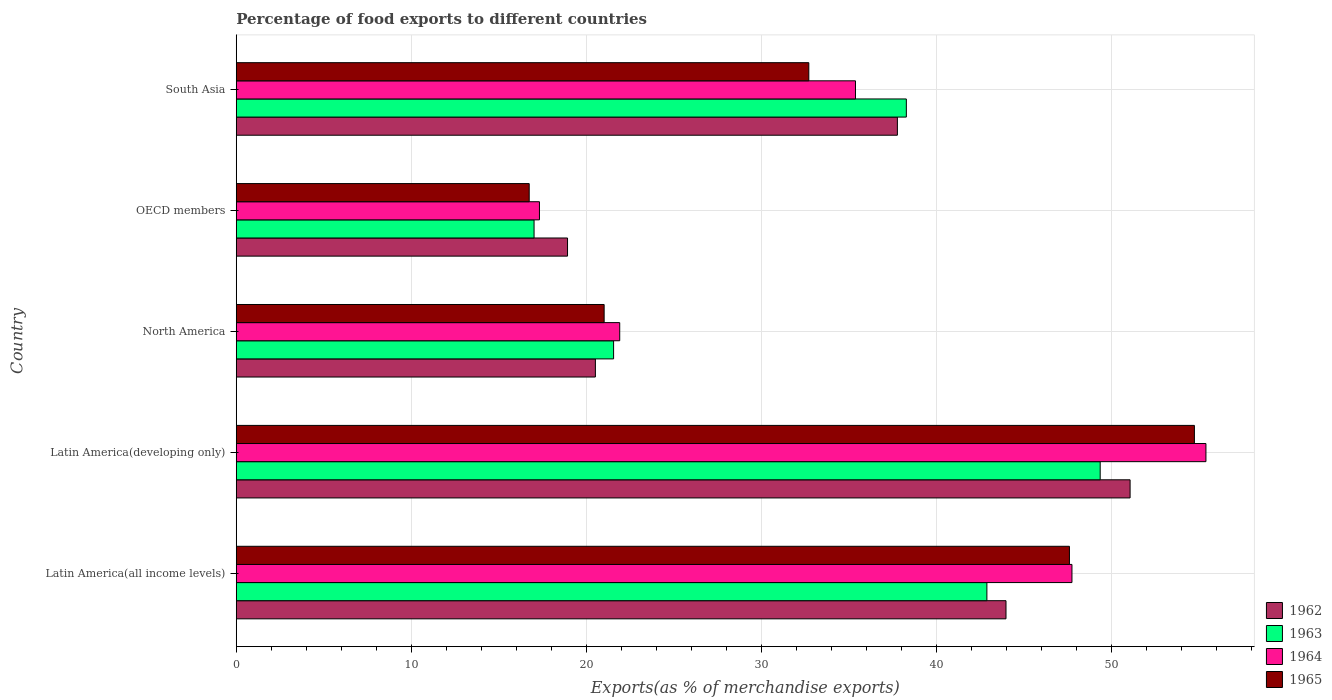How many different coloured bars are there?
Ensure brevity in your answer.  4. Are the number of bars on each tick of the Y-axis equal?
Provide a short and direct response. Yes. What is the label of the 4th group of bars from the top?
Keep it short and to the point. Latin America(developing only). In how many cases, is the number of bars for a given country not equal to the number of legend labels?
Offer a terse response. 0. What is the percentage of exports to different countries in 1963 in South Asia?
Your answer should be compact. 38.26. Across all countries, what is the maximum percentage of exports to different countries in 1962?
Provide a short and direct response. 51.04. Across all countries, what is the minimum percentage of exports to different countries in 1962?
Your answer should be very brief. 18.92. In which country was the percentage of exports to different countries in 1965 maximum?
Your answer should be very brief. Latin America(developing only). What is the total percentage of exports to different countries in 1963 in the graph?
Provide a short and direct response. 169.02. What is the difference between the percentage of exports to different countries in 1962 in Latin America(all income levels) and that in South Asia?
Your answer should be compact. 6.2. What is the difference between the percentage of exports to different countries in 1963 in Latin America(all income levels) and the percentage of exports to different countries in 1962 in Latin America(developing only)?
Keep it short and to the point. -8.18. What is the average percentage of exports to different countries in 1965 per country?
Give a very brief answer. 34.54. What is the difference between the percentage of exports to different countries in 1962 and percentage of exports to different countries in 1964 in North America?
Provide a succinct answer. -1.39. What is the ratio of the percentage of exports to different countries in 1965 in Latin America(developing only) to that in OECD members?
Keep it short and to the point. 3.27. Is the difference between the percentage of exports to different countries in 1962 in Latin America(all income levels) and OECD members greater than the difference between the percentage of exports to different countries in 1964 in Latin America(all income levels) and OECD members?
Offer a very short reply. No. What is the difference between the highest and the second highest percentage of exports to different countries in 1963?
Keep it short and to the point. 6.47. What is the difference between the highest and the lowest percentage of exports to different countries in 1964?
Provide a succinct answer. 38.06. In how many countries, is the percentage of exports to different countries in 1962 greater than the average percentage of exports to different countries in 1962 taken over all countries?
Offer a very short reply. 3. What does the 2nd bar from the top in North America represents?
Offer a very short reply. 1964. What does the 1st bar from the bottom in OECD members represents?
Your answer should be compact. 1962. How are the legend labels stacked?
Make the answer very short. Vertical. What is the title of the graph?
Offer a terse response. Percentage of food exports to different countries. What is the label or title of the X-axis?
Provide a short and direct response. Exports(as % of merchandise exports). What is the Exports(as % of merchandise exports) in 1962 in Latin America(all income levels)?
Your answer should be compact. 43.96. What is the Exports(as % of merchandise exports) in 1963 in Latin America(all income levels)?
Your response must be concise. 42.86. What is the Exports(as % of merchandise exports) in 1964 in Latin America(all income levels)?
Offer a very short reply. 47.72. What is the Exports(as % of merchandise exports) in 1965 in Latin America(all income levels)?
Ensure brevity in your answer.  47.58. What is the Exports(as % of merchandise exports) of 1962 in Latin America(developing only)?
Offer a terse response. 51.04. What is the Exports(as % of merchandise exports) in 1963 in Latin America(developing only)?
Your response must be concise. 49.33. What is the Exports(as % of merchandise exports) in 1964 in Latin America(developing only)?
Offer a very short reply. 55.37. What is the Exports(as % of merchandise exports) of 1965 in Latin America(developing only)?
Give a very brief answer. 54.71. What is the Exports(as % of merchandise exports) in 1962 in North America?
Keep it short and to the point. 20.51. What is the Exports(as % of merchandise exports) in 1963 in North America?
Your answer should be compact. 21.55. What is the Exports(as % of merchandise exports) of 1964 in North America?
Your answer should be compact. 21.9. What is the Exports(as % of merchandise exports) of 1965 in North America?
Offer a very short reply. 21.01. What is the Exports(as % of merchandise exports) of 1962 in OECD members?
Provide a short and direct response. 18.92. What is the Exports(as % of merchandise exports) in 1963 in OECD members?
Your response must be concise. 17.01. What is the Exports(as % of merchandise exports) of 1964 in OECD members?
Your answer should be compact. 17.31. What is the Exports(as % of merchandise exports) of 1965 in OECD members?
Make the answer very short. 16.73. What is the Exports(as % of merchandise exports) of 1962 in South Asia?
Ensure brevity in your answer.  37.75. What is the Exports(as % of merchandise exports) in 1963 in South Asia?
Provide a succinct answer. 38.26. What is the Exports(as % of merchandise exports) in 1964 in South Asia?
Your answer should be compact. 35.36. What is the Exports(as % of merchandise exports) of 1965 in South Asia?
Offer a very short reply. 32.7. Across all countries, what is the maximum Exports(as % of merchandise exports) of 1962?
Offer a terse response. 51.04. Across all countries, what is the maximum Exports(as % of merchandise exports) in 1963?
Offer a very short reply. 49.33. Across all countries, what is the maximum Exports(as % of merchandise exports) in 1964?
Make the answer very short. 55.37. Across all countries, what is the maximum Exports(as % of merchandise exports) of 1965?
Your answer should be very brief. 54.71. Across all countries, what is the minimum Exports(as % of merchandise exports) of 1962?
Your answer should be very brief. 18.92. Across all countries, what is the minimum Exports(as % of merchandise exports) in 1963?
Your response must be concise. 17.01. Across all countries, what is the minimum Exports(as % of merchandise exports) of 1964?
Provide a succinct answer. 17.31. Across all countries, what is the minimum Exports(as % of merchandise exports) of 1965?
Provide a succinct answer. 16.73. What is the total Exports(as % of merchandise exports) in 1962 in the graph?
Your answer should be compact. 172.18. What is the total Exports(as % of merchandise exports) in 1963 in the graph?
Offer a very short reply. 169.02. What is the total Exports(as % of merchandise exports) of 1964 in the graph?
Your answer should be compact. 177.67. What is the total Exports(as % of merchandise exports) in 1965 in the graph?
Provide a succinct answer. 172.72. What is the difference between the Exports(as % of merchandise exports) of 1962 in Latin America(all income levels) and that in Latin America(developing only)?
Ensure brevity in your answer.  -7.09. What is the difference between the Exports(as % of merchandise exports) in 1963 in Latin America(all income levels) and that in Latin America(developing only)?
Offer a terse response. -6.47. What is the difference between the Exports(as % of merchandise exports) in 1964 in Latin America(all income levels) and that in Latin America(developing only)?
Your answer should be compact. -7.65. What is the difference between the Exports(as % of merchandise exports) in 1965 in Latin America(all income levels) and that in Latin America(developing only)?
Your response must be concise. -7.14. What is the difference between the Exports(as % of merchandise exports) of 1962 in Latin America(all income levels) and that in North America?
Provide a succinct answer. 23.45. What is the difference between the Exports(as % of merchandise exports) in 1963 in Latin America(all income levels) and that in North America?
Provide a short and direct response. 21.32. What is the difference between the Exports(as % of merchandise exports) in 1964 in Latin America(all income levels) and that in North America?
Offer a terse response. 25.82. What is the difference between the Exports(as % of merchandise exports) in 1965 in Latin America(all income levels) and that in North America?
Offer a terse response. 26.57. What is the difference between the Exports(as % of merchandise exports) in 1962 in Latin America(all income levels) and that in OECD members?
Your response must be concise. 25.04. What is the difference between the Exports(as % of merchandise exports) in 1963 in Latin America(all income levels) and that in OECD members?
Give a very brief answer. 25.86. What is the difference between the Exports(as % of merchandise exports) of 1964 in Latin America(all income levels) and that in OECD members?
Ensure brevity in your answer.  30.41. What is the difference between the Exports(as % of merchandise exports) in 1965 in Latin America(all income levels) and that in OECD members?
Your answer should be very brief. 30.85. What is the difference between the Exports(as % of merchandise exports) of 1962 in Latin America(all income levels) and that in South Asia?
Your answer should be compact. 6.2. What is the difference between the Exports(as % of merchandise exports) in 1963 in Latin America(all income levels) and that in South Asia?
Offer a very short reply. 4.6. What is the difference between the Exports(as % of merchandise exports) in 1964 in Latin America(all income levels) and that in South Asia?
Give a very brief answer. 12.36. What is the difference between the Exports(as % of merchandise exports) in 1965 in Latin America(all income levels) and that in South Asia?
Provide a succinct answer. 14.88. What is the difference between the Exports(as % of merchandise exports) of 1962 in Latin America(developing only) and that in North America?
Make the answer very short. 30.53. What is the difference between the Exports(as % of merchandise exports) in 1963 in Latin America(developing only) and that in North America?
Your answer should be very brief. 27.79. What is the difference between the Exports(as % of merchandise exports) in 1964 in Latin America(developing only) and that in North America?
Keep it short and to the point. 33.48. What is the difference between the Exports(as % of merchandise exports) in 1965 in Latin America(developing only) and that in North America?
Give a very brief answer. 33.71. What is the difference between the Exports(as % of merchandise exports) of 1962 in Latin America(developing only) and that in OECD members?
Make the answer very short. 32.12. What is the difference between the Exports(as % of merchandise exports) in 1963 in Latin America(developing only) and that in OECD members?
Your answer should be very brief. 32.33. What is the difference between the Exports(as % of merchandise exports) in 1964 in Latin America(developing only) and that in OECD members?
Offer a terse response. 38.06. What is the difference between the Exports(as % of merchandise exports) of 1965 in Latin America(developing only) and that in OECD members?
Offer a terse response. 37.99. What is the difference between the Exports(as % of merchandise exports) in 1962 in Latin America(developing only) and that in South Asia?
Your answer should be compact. 13.29. What is the difference between the Exports(as % of merchandise exports) in 1963 in Latin America(developing only) and that in South Asia?
Offer a very short reply. 11.07. What is the difference between the Exports(as % of merchandise exports) in 1964 in Latin America(developing only) and that in South Asia?
Offer a very short reply. 20.01. What is the difference between the Exports(as % of merchandise exports) in 1965 in Latin America(developing only) and that in South Asia?
Offer a terse response. 22.02. What is the difference between the Exports(as % of merchandise exports) in 1962 in North America and that in OECD members?
Your answer should be very brief. 1.59. What is the difference between the Exports(as % of merchandise exports) in 1963 in North America and that in OECD members?
Make the answer very short. 4.54. What is the difference between the Exports(as % of merchandise exports) in 1964 in North America and that in OECD members?
Provide a succinct answer. 4.58. What is the difference between the Exports(as % of merchandise exports) in 1965 in North America and that in OECD members?
Give a very brief answer. 4.28. What is the difference between the Exports(as % of merchandise exports) of 1962 in North America and that in South Asia?
Provide a short and direct response. -17.25. What is the difference between the Exports(as % of merchandise exports) in 1963 in North America and that in South Asia?
Your answer should be very brief. -16.72. What is the difference between the Exports(as % of merchandise exports) of 1964 in North America and that in South Asia?
Provide a succinct answer. -13.46. What is the difference between the Exports(as % of merchandise exports) of 1965 in North America and that in South Asia?
Your answer should be very brief. -11.69. What is the difference between the Exports(as % of merchandise exports) of 1962 in OECD members and that in South Asia?
Your answer should be compact. -18.84. What is the difference between the Exports(as % of merchandise exports) of 1963 in OECD members and that in South Asia?
Make the answer very short. -21.26. What is the difference between the Exports(as % of merchandise exports) of 1964 in OECD members and that in South Asia?
Make the answer very short. -18.05. What is the difference between the Exports(as % of merchandise exports) of 1965 in OECD members and that in South Asia?
Keep it short and to the point. -15.97. What is the difference between the Exports(as % of merchandise exports) in 1962 in Latin America(all income levels) and the Exports(as % of merchandise exports) in 1963 in Latin America(developing only)?
Your answer should be very brief. -5.38. What is the difference between the Exports(as % of merchandise exports) of 1962 in Latin America(all income levels) and the Exports(as % of merchandise exports) of 1964 in Latin America(developing only)?
Your response must be concise. -11.42. What is the difference between the Exports(as % of merchandise exports) of 1962 in Latin America(all income levels) and the Exports(as % of merchandise exports) of 1965 in Latin America(developing only)?
Ensure brevity in your answer.  -10.76. What is the difference between the Exports(as % of merchandise exports) of 1963 in Latin America(all income levels) and the Exports(as % of merchandise exports) of 1964 in Latin America(developing only)?
Provide a short and direct response. -12.51. What is the difference between the Exports(as % of merchandise exports) in 1963 in Latin America(all income levels) and the Exports(as % of merchandise exports) in 1965 in Latin America(developing only)?
Your answer should be very brief. -11.85. What is the difference between the Exports(as % of merchandise exports) of 1964 in Latin America(all income levels) and the Exports(as % of merchandise exports) of 1965 in Latin America(developing only)?
Offer a very short reply. -6.99. What is the difference between the Exports(as % of merchandise exports) in 1962 in Latin America(all income levels) and the Exports(as % of merchandise exports) in 1963 in North America?
Offer a very short reply. 22.41. What is the difference between the Exports(as % of merchandise exports) in 1962 in Latin America(all income levels) and the Exports(as % of merchandise exports) in 1964 in North America?
Your answer should be compact. 22.06. What is the difference between the Exports(as % of merchandise exports) of 1962 in Latin America(all income levels) and the Exports(as % of merchandise exports) of 1965 in North America?
Provide a short and direct response. 22.95. What is the difference between the Exports(as % of merchandise exports) in 1963 in Latin America(all income levels) and the Exports(as % of merchandise exports) in 1964 in North America?
Provide a short and direct response. 20.97. What is the difference between the Exports(as % of merchandise exports) in 1963 in Latin America(all income levels) and the Exports(as % of merchandise exports) in 1965 in North America?
Offer a terse response. 21.86. What is the difference between the Exports(as % of merchandise exports) of 1964 in Latin America(all income levels) and the Exports(as % of merchandise exports) of 1965 in North America?
Your response must be concise. 26.71. What is the difference between the Exports(as % of merchandise exports) in 1962 in Latin America(all income levels) and the Exports(as % of merchandise exports) in 1963 in OECD members?
Your answer should be compact. 26.95. What is the difference between the Exports(as % of merchandise exports) in 1962 in Latin America(all income levels) and the Exports(as % of merchandise exports) in 1964 in OECD members?
Ensure brevity in your answer.  26.64. What is the difference between the Exports(as % of merchandise exports) of 1962 in Latin America(all income levels) and the Exports(as % of merchandise exports) of 1965 in OECD members?
Provide a short and direct response. 27.23. What is the difference between the Exports(as % of merchandise exports) in 1963 in Latin America(all income levels) and the Exports(as % of merchandise exports) in 1964 in OECD members?
Make the answer very short. 25.55. What is the difference between the Exports(as % of merchandise exports) of 1963 in Latin America(all income levels) and the Exports(as % of merchandise exports) of 1965 in OECD members?
Offer a very short reply. 26.14. What is the difference between the Exports(as % of merchandise exports) of 1964 in Latin America(all income levels) and the Exports(as % of merchandise exports) of 1965 in OECD members?
Make the answer very short. 30.99. What is the difference between the Exports(as % of merchandise exports) of 1962 in Latin America(all income levels) and the Exports(as % of merchandise exports) of 1963 in South Asia?
Make the answer very short. 5.69. What is the difference between the Exports(as % of merchandise exports) of 1962 in Latin America(all income levels) and the Exports(as % of merchandise exports) of 1964 in South Asia?
Make the answer very short. 8.6. What is the difference between the Exports(as % of merchandise exports) of 1962 in Latin America(all income levels) and the Exports(as % of merchandise exports) of 1965 in South Asia?
Your response must be concise. 11.26. What is the difference between the Exports(as % of merchandise exports) in 1963 in Latin America(all income levels) and the Exports(as % of merchandise exports) in 1964 in South Asia?
Your response must be concise. 7.5. What is the difference between the Exports(as % of merchandise exports) in 1963 in Latin America(all income levels) and the Exports(as % of merchandise exports) in 1965 in South Asia?
Keep it short and to the point. 10.17. What is the difference between the Exports(as % of merchandise exports) in 1964 in Latin America(all income levels) and the Exports(as % of merchandise exports) in 1965 in South Asia?
Make the answer very short. 15.03. What is the difference between the Exports(as % of merchandise exports) in 1962 in Latin America(developing only) and the Exports(as % of merchandise exports) in 1963 in North America?
Ensure brevity in your answer.  29.49. What is the difference between the Exports(as % of merchandise exports) in 1962 in Latin America(developing only) and the Exports(as % of merchandise exports) in 1964 in North America?
Provide a short and direct response. 29.14. What is the difference between the Exports(as % of merchandise exports) of 1962 in Latin America(developing only) and the Exports(as % of merchandise exports) of 1965 in North America?
Offer a very short reply. 30.03. What is the difference between the Exports(as % of merchandise exports) in 1963 in Latin America(developing only) and the Exports(as % of merchandise exports) in 1964 in North America?
Offer a terse response. 27.44. What is the difference between the Exports(as % of merchandise exports) in 1963 in Latin America(developing only) and the Exports(as % of merchandise exports) in 1965 in North America?
Provide a succinct answer. 28.33. What is the difference between the Exports(as % of merchandise exports) of 1964 in Latin America(developing only) and the Exports(as % of merchandise exports) of 1965 in North America?
Provide a short and direct response. 34.37. What is the difference between the Exports(as % of merchandise exports) in 1962 in Latin America(developing only) and the Exports(as % of merchandise exports) in 1963 in OECD members?
Give a very brief answer. 34.04. What is the difference between the Exports(as % of merchandise exports) in 1962 in Latin America(developing only) and the Exports(as % of merchandise exports) in 1964 in OECD members?
Your answer should be compact. 33.73. What is the difference between the Exports(as % of merchandise exports) of 1962 in Latin America(developing only) and the Exports(as % of merchandise exports) of 1965 in OECD members?
Make the answer very short. 34.31. What is the difference between the Exports(as % of merchandise exports) of 1963 in Latin America(developing only) and the Exports(as % of merchandise exports) of 1964 in OECD members?
Your answer should be very brief. 32.02. What is the difference between the Exports(as % of merchandise exports) of 1963 in Latin America(developing only) and the Exports(as % of merchandise exports) of 1965 in OECD members?
Offer a terse response. 32.61. What is the difference between the Exports(as % of merchandise exports) in 1964 in Latin America(developing only) and the Exports(as % of merchandise exports) in 1965 in OECD members?
Offer a terse response. 38.64. What is the difference between the Exports(as % of merchandise exports) of 1962 in Latin America(developing only) and the Exports(as % of merchandise exports) of 1963 in South Asia?
Provide a short and direct response. 12.78. What is the difference between the Exports(as % of merchandise exports) in 1962 in Latin America(developing only) and the Exports(as % of merchandise exports) in 1964 in South Asia?
Provide a short and direct response. 15.68. What is the difference between the Exports(as % of merchandise exports) in 1962 in Latin America(developing only) and the Exports(as % of merchandise exports) in 1965 in South Asia?
Provide a short and direct response. 18.35. What is the difference between the Exports(as % of merchandise exports) in 1963 in Latin America(developing only) and the Exports(as % of merchandise exports) in 1964 in South Asia?
Provide a short and direct response. 13.97. What is the difference between the Exports(as % of merchandise exports) in 1963 in Latin America(developing only) and the Exports(as % of merchandise exports) in 1965 in South Asia?
Ensure brevity in your answer.  16.64. What is the difference between the Exports(as % of merchandise exports) of 1964 in Latin America(developing only) and the Exports(as % of merchandise exports) of 1965 in South Asia?
Ensure brevity in your answer.  22.68. What is the difference between the Exports(as % of merchandise exports) in 1962 in North America and the Exports(as % of merchandise exports) in 1963 in OECD members?
Provide a short and direct response. 3.5. What is the difference between the Exports(as % of merchandise exports) in 1962 in North America and the Exports(as % of merchandise exports) in 1964 in OECD members?
Your response must be concise. 3.19. What is the difference between the Exports(as % of merchandise exports) of 1962 in North America and the Exports(as % of merchandise exports) of 1965 in OECD members?
Your response must be concise. 3.78. What is the difference between the Exports(as % of merchandise exports) of 1963 in North America and the Exports(as % of merchandise exports) of 1964 in OECD members?
Your answer should be compact. 4.23. What is the difference between the Exports(as % of merchandise exports) of 1963 in North America and the Exports(as % of merchandise exports) of 1965 in OECD members?
Offer a terse response. 4.82. What is the difference between the Exports(as % of merchandise exports) in 1964 in North America and the Exports(as % of merchandise exports) in 1965 in OECD members?
Your answer should be very brief. 5.17. What is the difference between the Exports(as % of merchandise exports) of 1962 in North America and the Exports(as % of merchandise exports) of 1963 in South Asia?
Make the answer very short. -17.76. What is the difference between the Exports(as % of merchandise exports) in 1962 in North America and the Exports(as % of merchandise exports) in 1964 in South Asia?
Give a very brief answer. -14.85. What is the difference between the Exports(as % of merchandise exports) of 1962 in North America and the Exports(as % of merchandise exports) of 1965 in South Asia?
Keep it short and to the point. -12.19. What is the difference between the Exports(as % of merchandise exports) of 1963 in North America and the Exports(as % of merchandise exports) of 1964 in South Asia?
Your response must be concise. -13.81. What is the difference between the Exports(as % of merchandise exports) of 1963 in North America and the Exports(as % of merchandise exports) of 1965 in South Asia?
Your answer should be very brief. -11.15. What is the difference between the Exports(as % of merchandise exports) of 1964 in North America and the Exports(as % of merchandise exports) of 1965 in South Asia?
Your response must be concise. -10.8. What is the difference between the Exports(as % of merchandise exports) of 1962 in OECD members and the Exports(as % of merchandise exports) of 1963 in South Asia?
Your response must be concise. -19.35. What is the difference between the Exports(as % of merchandise exports) in 1962 in OECD members and the Exports(as % of merchandise exports) in 1964 in South Asia?
Keep it short and to the point. -16.44. What is the difference between the Exports(as % of merchandise exports) of 1962 in OECD members and the Exports(as % of merchandise exports) of 1965 in South Asia?
Give a very brief answer. -13.78. What is the difference between the Exports(as % of merchandise exports) in 1963 in OECD members and the Exports(as % of merchandise exports) in 1964 in South Asia?
Offer a very short reply. -18.35. What is the difference between the Exports(as % of merchandise exports) of 1963 in OECD members and the Exports(as % of merchandise exports) of 1965 in South Asia?
Your response must be concise. -15.69. What is the difference between the Exports(as % of merchandise exports) of 1964 in OECD members and the Exports(as % of merchandise exports) of 1965 in South Asia?
Make the answer very short. -15.38. What is the average Exports(as % of merchandise exports) in 1962 per country?
Ensure brevity in your answer.  34.44. What is the average Exports(as % of merchandise exports) in 1963 per country?
Give a very brief answer. 33.8. What is the average Exports(as % of merchandise exports) in 1964 per country?
Provide a short and direct response. 35.53. What is the average Exports(as % of merchandise exports) of 1965 per country?
Your response must be concise. 34.54. What is the difference between the Exports(as % of merchandise exports) of 1962 and Exports(as % of merchandise exports) of 1963 in Latin America(all income levels)?
Offer a very short reply. 1.09. What is the difference between the Exports(as % of merchandise exports) of 1962 and Exports(as % of merchandise exports) of 1964 in Latin America(all income levels)?
Your response must be concise. -3.77. What is the difference between the Exports(as % of merchandise exports) in 1962 and Exports(as % of merchandise exports) in 1965 in Latin America(all income levels)?
Make the answer very short. -3.62. What is the difference between the Exports(as % of merchandise exports) of 1963 and Exports(as % of merchandise exports) of 1964 in Latin America(all income levels)?
Offer a terse response. -4.86. What is the difference between the Exports(as % of merchandise exports) of 1963 and Exports(as % of merchandise exports) of 1965 in Latin America(all income levels)?
Your answer should be compact. -4.71. What is the difference between the Exports(as % of merchandise exports) in 1964 and Exports(as % of merchandise exports) in 1965 in Latin America(all income levels)?
Your answer should be very brief. 0.14. What is the difference between the Exports(as % of merchandise exports) in 1962 and Exports(as % of merchandise exports) in 1963 in Latin America(developing only)?
Give a very brief answer. 1.71. What is the difference between the Exports(as % of merchandise exports) of 1962 and Exports(as % of merchandise exports) of 1964 in Latin America(developing only)?
Your answer should be very brief. -4.33. What is the difference between the Exports(as % of merchandise exports) in 1962 and Exports(as % of merchandise exports) in 1965 in Latin America(developing only)?
Keep it short and to the point. -3.67. What is the difference between the Exports(as % of merchandise exports) of 1963 and Exports(as % of merchandise exports) of 1964 in Latin America(developing only)?
Ensure brevity in your answer.  -6.04. What is the difference between the Exports(as % of merchandise exports) of 1963 and Exports(as % of merchandise exports) of 1965 in Latin America(developing only)?
Give a very brief answer. -5.38. What is the difference between the Exports(as % of merchandise exports) of 1964 and Exports(as % of merchandise exports) of 1965 in Latin America(developing only)?
Your answer should be very brief. 0.66. What is the difference between the Exports(as % of merchandise exports) in 1962 and Exports(as % of merchandise exports) in 1963 in North America?
Your answer should be compact. -1.04. What is the difference between the Exports(as % of merchandise exports) in 1962 and Exports(as % of merchandise exports) in 1964 in North America?
Offer a terse response. -1.39. What is the difference between the Exports(as % of merchandise exports) in 1962 and Exports(as % of merchandise exports) in 1965 in North America?
Give a very brief answer. -0.5. What is the difference between the Exports(as % of merchandise exports) in 1963 and Exports(as % of merchandise exports) in 1964 in North America?
Offer a very short reply. -0.35. What is the difference between the Exports(as % of merchandise exports) of 1963 and Exports(as % of merchandise exports) of 1965 in North America?
Provide a succinct answer. 0.54. What is the difference between the Exports(as % of merchandise exports) of 1964 and Exports(as % of merchandise exports) of 1965 in North America?
Your answer should be compact. 0.89. What is the difference between the Exports(as % of merchandise exports) in 1962 and Exports(as % of merchandise exports) in 1963 in OECD members?
Keep it short and to the point. 1.91. What is the difference between the Exports(as % of merchandise exports) in 1962 and Exports(as % of merchandise exports) in 1964 in OECD members?
Your answer should be very brief. 1.6. What is the difference between the Exports(as % of merchandise exports) of 1962 and Exports(as % of merchandise exports) of 1965 in OECD members?
Your response must be concise. 2.19. What is the difference between the Exports(as % of merchandise exports) in 1963 and Exports(as % of merchandise exports) in 1964 in OECD members?
Offer a terse response. -0.31. What is the difference between the Exports(as % of merchandise exports) in 1963 and Exports(as % of merchandise exports) in 1965 in OECD members?
Provide a succinct answer. 0.28. What is the difference between the Exports(as % of merchandise exports) in 1964 and Exports(as % of merchandise exports) in 1965 in OECD members?
Give a very brief answer. 0.59. What is the difference between the Exports(as % of merchandise exports) in 1962 and Exports(as % of merchandise exports) in 1963 in South Asia?
Ensure brevity in your answer.  -0.51. What is the difference between the Exports(as % of merchandise exports) of 1962 and Exports(as % of merchandise exports) of 1964 in South Asia?
Keep it short and to the point. 2.39. What is the difference between the Exports(as % of merchandise exports) in 1962 and Exports(as % of merchandise exports) in 1965 in South Asia?
Provide a succinct answer. 5.06. What is the difference between the Exports(as % of merchandise exports) of 1963 and Exports(as % of merchandise exports) of 1964 in South Asia?
Provide a succinct answer. 2.9. What is the difference between the Exports(as % of merchandise exports) of 1963 and Exports(as % of merchandise exports) of 1965 in South Asia?
Provide a short and direct response. 5.57. What is the difference between the Exports(as % of merchandise exports) in 1964 and Exports(as % of merchandise exports) in 1965 in South Asia?
Make the answer very short. 2.66. What is the ratio of the Exports(as % of merchandise exports) in 1962 in Latin America(all income levels) to that in Latin America(developing only)?
Your answer should be compact. 0.86. What is the ratio of the Exports(as % of merchandise exports) of 1963 in Latin America(all income levels) to that in Latin America(developing only)?
Provide a succinct answer. 0.87. What is the ratio of the Exports(as % of merchandise exports) of 1964 in Latin America(all income levels) to that in Latin America(developing only)?
Your answer should be compact. 0.86. What is the ratio of the Exports(as % of merchandise exports) in 1965 in Latin America(all income levels) to that in Latin America(developing only)?
Make the answer very short. 0.87. What is the ratio of the Exports(as % of merchandise exports) of 1962 in Latin America(all income levels) to that in North America?
Offer a very short reply. 2.14. What is the ratio of the Exports(as % of merchandise exports) in 1963 in Latin America(all income levels) to that in North America?
Your response must be concise. 1.99. What is the ratio of the Exports(as % of merchandise exports) of 1964 in Latin America(all income levels) to that in North America?
Provide a succinct answer. 2.18. What is the ratio of the Exports(as % of merchandise exports) of 1965 in Latin America(all income levels) to that in North America?
Provide a succinct answer. 2.26. What is the ratio of the Exports(as % of merchandise exports) in 1962 in Latin America(all income levels) to that in OECD members?
Your answer should be very brief. 2.32. What is the ratio of the Exports(as % of merchandise exports) in 1963 in Latin America(all income levels) to that in OECD members?
Offer a terse response. 2.52. What is the ratio of the Exports(as % of merchandise exports) of 1964 in Latin America(all income levels) to that in OECD members?
Offer a terse response. 2.76. What is the ratio of the Exports(as % of merchandise exports) of 1965 in Latin America(all income levels) to that in OECD members?
Offer a terse response. 2.84. What is the ratio of the Exports(as % of merchandise exports) of 1962 in Latin America(all income levels) to that in South Asia?
Make the answer very short. 1.16. What is the ratio of the Exports(as % of merchandise exports) in 1963 in Latin America(all income levels) to that in South Asia?
Provide a short and direct response. 1.12. What is the ratio of the Exports(as % of merchandise exports) in 1964 in Latin America(all income levels) to that in South Asia?
Keep it short and to the point. 1.35. What is the ratio of the Exports(as % of merchandise exports) in 1965 in Latin America(all income levels) to that in South Asia?
Your response must be concise. 1.46. What is the ratio of the Exports(as % of merchandise exports) in 1962 in Latin America(developing only) to that in North America?
Offer a very short reply. 2.49. What is the ratio of the Exports(as % of merchandise exports) of 1963 in Latin America(developing only) to that in North America?
Make the answer very short. 2.29. What is the ratio of the Exports(as % of merchandise exports) in 1964 in Latin America(developing only) to that in North America?
Offer a very short reply. 2.53. What is the ratio of the Exports(as % of merchandise exports) of 1965 in Latin America(developing only) to that in North America?
Your answer should be very brief. 2.6. What is the ratio of the Exports(as % of merchandise exports) in 1962 in Latin America(developing only) to that in OECD members?
Provide a short and direct response. 2.7. What is the ratio of the Exports(as % of merchandise exports) of 1963 in Latin America(developing only) to that in OECD members?
Make the answer very short. 2.9. What is the ratio of the Exports(as % of merchandise exports) in 1964 in Latin America(developing only) to that in OECD members?
Provide a short and direct response. 3.2. What is the ratio of the Exports(as % of merchandise exports) in 1965 in Latin America(developing only) to that in OECD members?
Provide a succinct answer. 3.27. What is the ratio of the Exports(as % of merchandise exports) in 1962 in Latin America(developing only) to that in South Asia?
Ensure brevity in your answer.  1.35. What is the ratio of the Exports(as % of merchandise exports) of 1963 in Latin America(developing only) to that in South Asia?
Your answer should be compact. 1.29. What is the ratio of the Exports(as % of merchandise exports) in 1964 in Latin America(developing only) to that in South Asia?
Offer a very short reply. 1.57. What is the ratio of the Exports(as % of merchandise exports) in 1965 in Latin America(developing only) to that in South Asia?
Ensure brevity in your answer.  1.67. What is the ratio of the Exports(as % of merchandise exports) of 1962 in North America to that in OECD members?
Provide a succinct answer. 1.08. What is the ratio of the Exports(as % of merchandise exports) of 1963 in North America to that in OECD members?
Provide a succinct answer. 1.27. What is the ratio of the Exports(as % of merchandise exports) of 1964 in North America to that in OECD members?
Your answer should be compact. 1.26. What is the ratio of the Exports(as % of merchandise exports) of 1965 in North America to that in OECD members?
Make the answer very short. 1.26. What is the ratio of the Exports(as % of merchandise exports) of 1962 in North America to that in South Asia?
Offer a terse response. 0.54. What is the ratio of the Exports(as % of merchandise exports) of 1963 in North America to that in South Asia?
Your answer should be compact. 0.56. What is the ratio of the Exports(as % of merchandise exports) in 1964 in North America to that in South Asia?
Provide a succinct answer. 0.62. What is the ratio of the Exports(as % of merchandise exports) of 1965 in North America to that in South Asia?
Give a very brief answer. 0.64. What is the ratio of the Exports(as % of merchandise exports) in 1962 in OECD members to that in South Asia?
Offer a very short reply. 0.5. What is the ratio of the Exports(as % of merchandise exports) in 1963 in OECD members to that in South Asia?
Provide a short and direct response. 0.44. What is the ratio of the Exports(as % of merchandise exports) of 1964 in OECD members to that in South Asia?
Give a very brief answer. 0.49. What is the ratio of the Exports(as % of merchandise exports) of 1965 in OECD members to that in South Asia?
Offer a very short reply. 0.51. What is the difference between the highest and the second highest Exports(as % of merchandise exports) of 1962?
Make the answer very short. 7.09. What is the difference between the highest and the second highest Exports(as % of merchandise exports) of 1963?
Your answer should be very brief. 6.47. What is the difference between the highest and the second highest Exports(as % of merchandise exports) in 1964?
Give a very brief answer. 7.65. What is the difference between the highest and the second highest Exports(as % of merchandise exports) in 1965?
Your answer should be very brief. 7.14. What is the difference between the highest and the lowest Exports(as % of merchandise exports) of 1962?
Offer a terse response. 32.12. What is the difference between the highest and the lowest Exports(as % of merchandise exports) in 1963?
Provide a short and direct response. 32.33. What is the difference between the highest and the lowest Exports(as % of merchandise exports) of 1964?
Ensure brevity in your answer.  38.06. What is the difference between the highest and the lowest Exports(as % of merchandise exports) of 1965?
Provide a succinct answer. 37.99. 